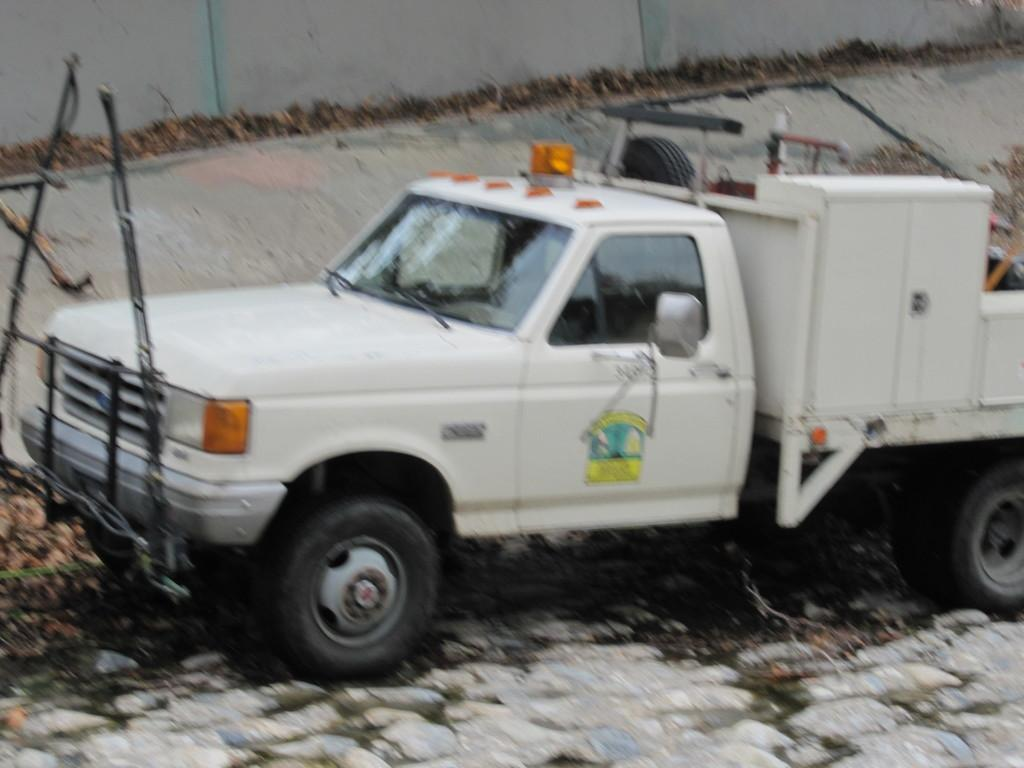What is the main subject of the image? There is a vehicle in the image. What can be seen at the top of the image? There is a wall at the top of the image. What is located on the left side of the image? There is an object on the left side of the image. What type of stem can be seen growing from the vehicle in the image? There is no stem growing from the vehicle in the image. What musical instrument is being played by the vehicle in the image? The vehicle is not playing a musical instrument in the image. 